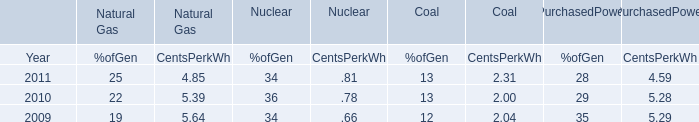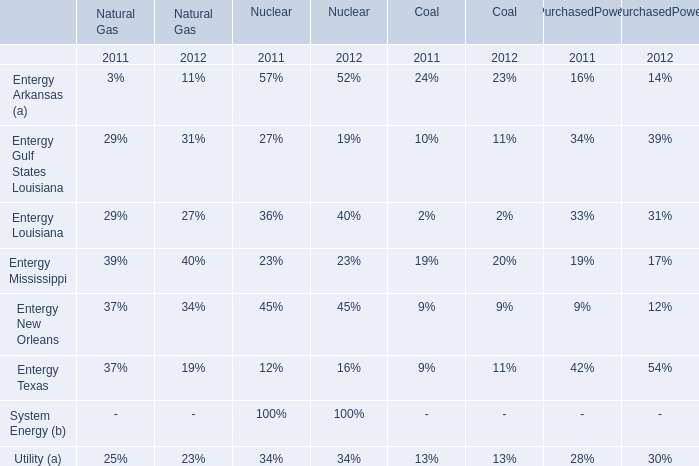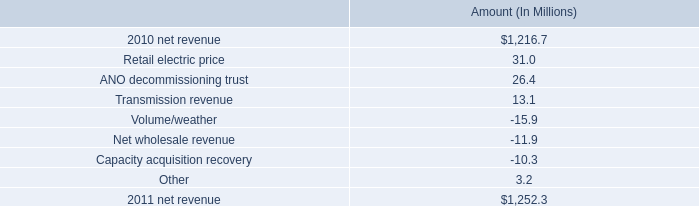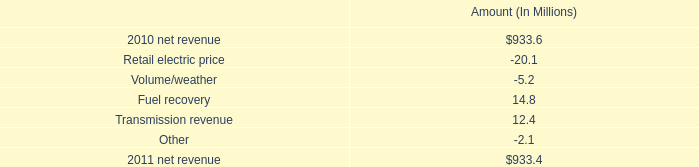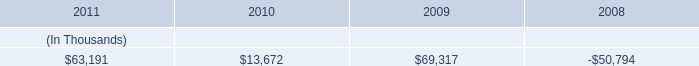what was the ratio of the net income increase in 2010 to the decrease in 2011 
Computations: (105.7 / 7.7)
Answer: 13.72727. 